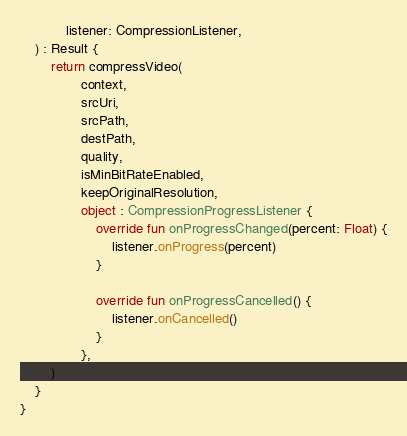Convert code to text. <code><loc_0><loc_0><loc_500><loc_500><_Kotlin_>            listener: CompressionListener,
    ) : Result {
        return compressVideo(
                context,
                srcUri,
                srcPath,
                destPath,
                quality,
                isMinBitRateEnabled,
                keepOriginalResolution,
                object : CompressionProgressListener {
                    override fun onProgressChanged(percent: Float) {
                        listener.onProgress(percent)
                    }

                    override fun onProgressCancelled() {
                        listener.onCancelled()
                    }
                },
        )
    }
}
</code> 